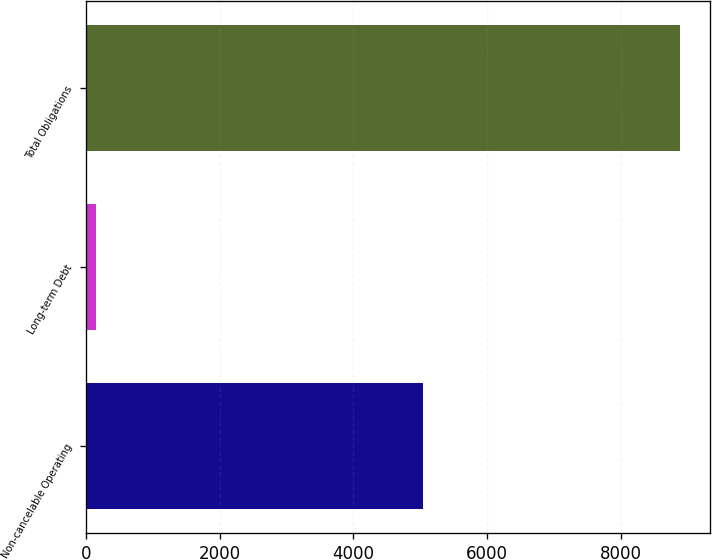Convert chart. <chart><loc_0><loc_0><loc_500><loc_500><bar_chart><fcel>Non-cancelable Operating<fcel>Long-term Debt<fcel>Total Obligations<nl><fcel>5034<fcel>150<fcel>8884<nl></chart> 